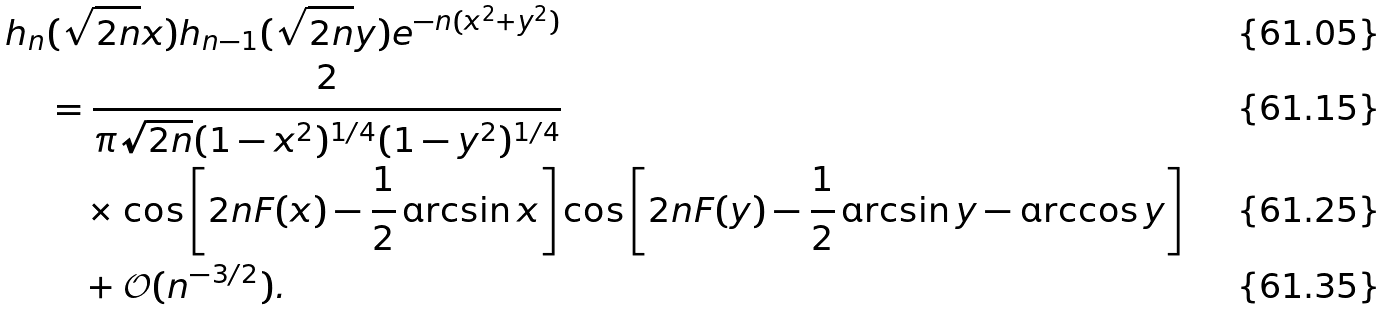Convert formula to latex. <formula><loc_0><loc_0><loc_500><loc_500>h _ { n } & ( \sqrt { 2 n } x ) h _ { n - 1 } ( \sqrt { 2 n } y ) e ^ { - n ( x ^ { 2 } + y ^ { 2 } ) } \\ & = \frac { 2 } { \pi \sqrt { 2 n } ( 1 - x ^ { 2 } ) ^ { 1 / 4 } ( 1 - y ^ { 2 } ) ^ { 1 / 4 } } \\ & \quad \times \cos \left [ 2 n F ( x ) - \frac { 1 } { 2 } \arcsin x \right ] \cos \left [ 2 n F ( y ) - \frac { 1 } { 2 } \arcsin y - \arccos y \right ] \\ & \quad + \mathcal { O } ( n ^ { - 3 / 2 } ) .</formula> 